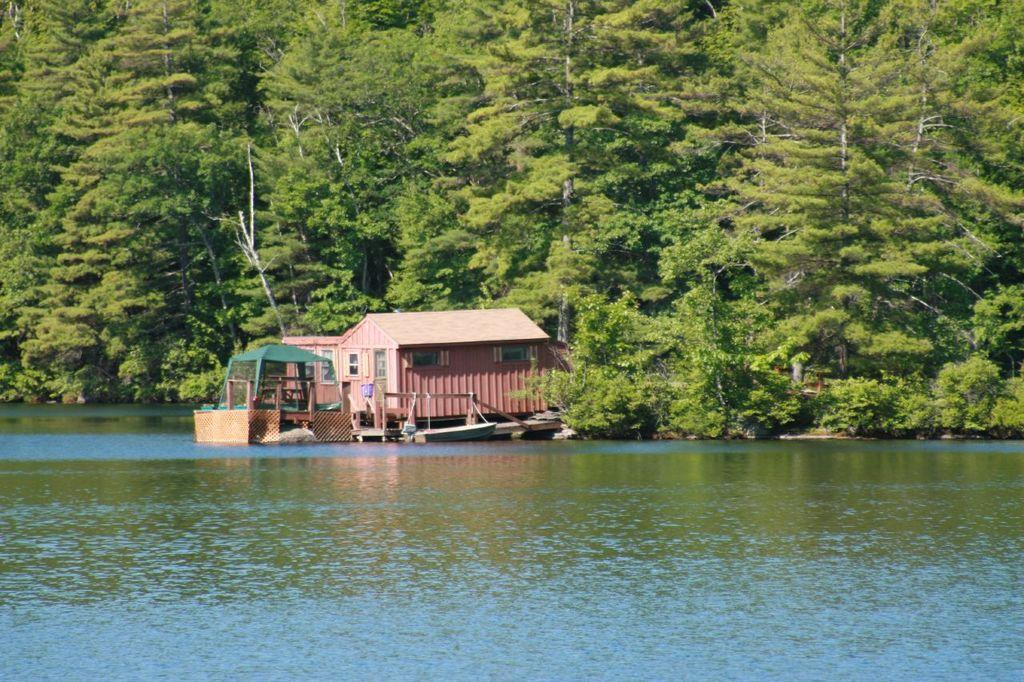What type of structure is present in the image? There is a house in the image. What is located on the water in the image? There is a boat on the water in the image. What can be seen in the background of the image? Trees are visible in the background of the image. Can you find the receipt for the boat purchase in the image? There is no receipt present in the image; it only shows a house, a boat, and trees in the background. Is there a note attached to the house in the image? There is no note visible in the image; it only shows a house, a boat, and trees in the background. 